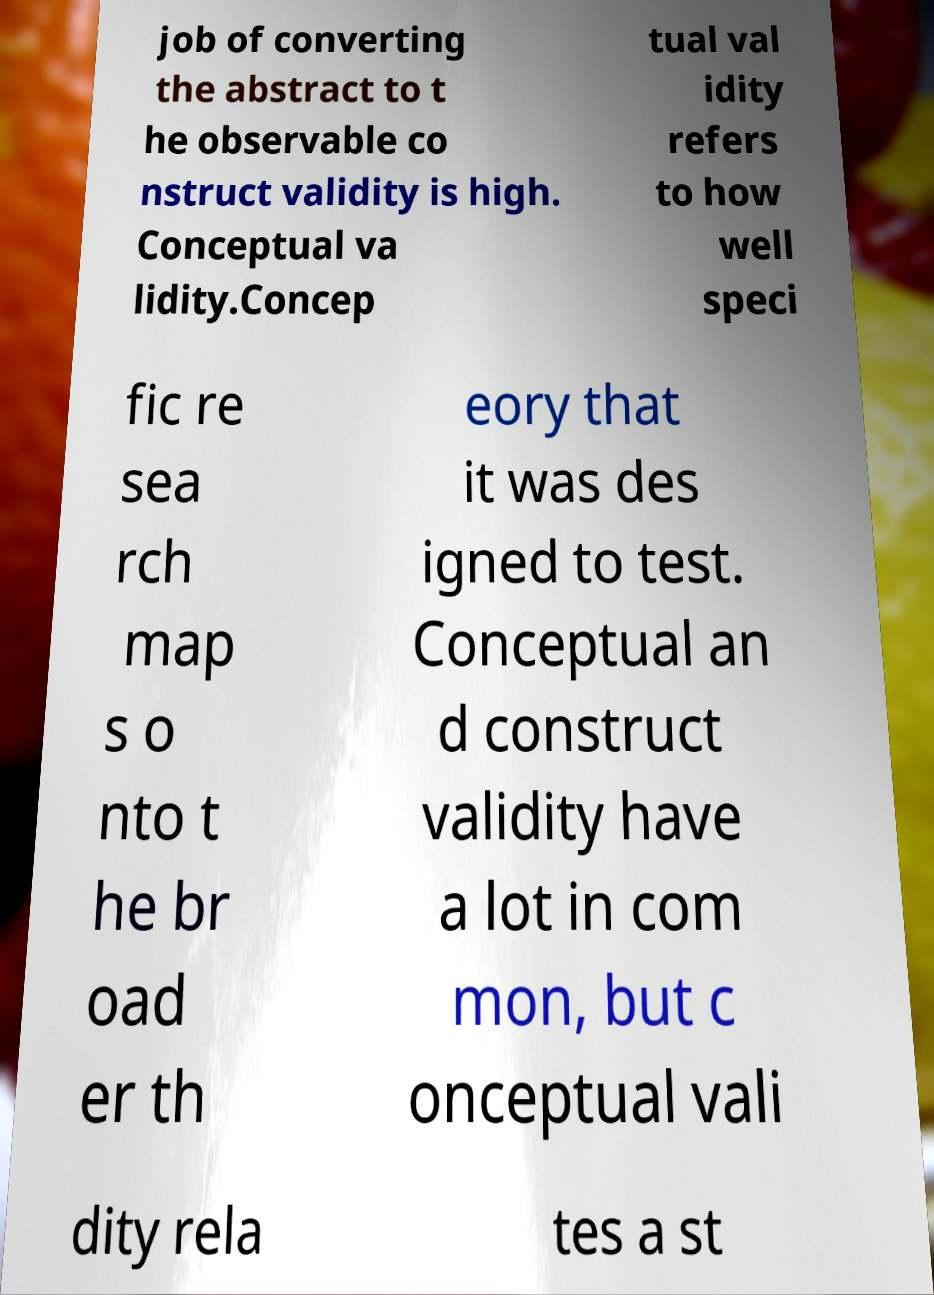There's text embedded in this image that I need extracted. Can you transcribe it verbatim? job of converting the abstract to t he observable co nstruct validity is high. Conceptual va lidity.Concep tual val idity refers to how well speci fic re sea rch map s o nto t he br oad er th eory that it was des igned to test. Conceptual an d construct validity have a lot in com mon, but c onceptual vali dity rela tes a st 